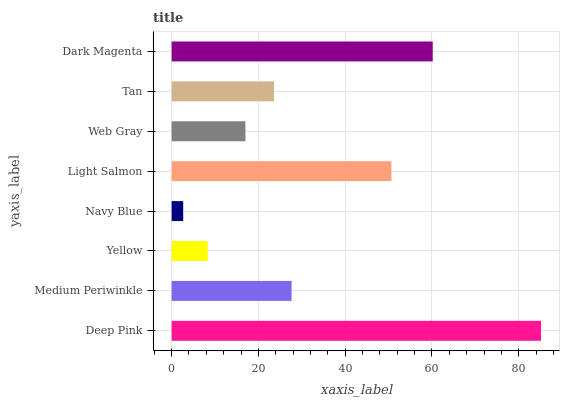Is Navy Blue the minimum?
Answer yes or no. Yes. Is Deep Pink the maximum?
Answer yes or no. Yes. Is Medium Periwinkle the minimum?
Answer yes or no. No. Is Medium Periwinkle the maximum?
Answer yes or no. No. Is Deep Pink greater than Medium Periwinkle?
Answer yes or no. Yes. Is Medium Periwinkle less than Deep Pink?
Answer yes or no. Yes. Is Medium Periwinkle greater than Deep Pink?
Answer yes or no. No. Is Deep Pink less than Medium Periwinkle?
Answer yes or no. No. Is Medium Periwinkle the high median?
Answer yes or no. Yes. Is Tan the low median?
Answer yes or no. Yes. Is Dark Magenta the high median?
Answer yes or no. No. Is Yellow the low median?
Answer yes or no. No. 